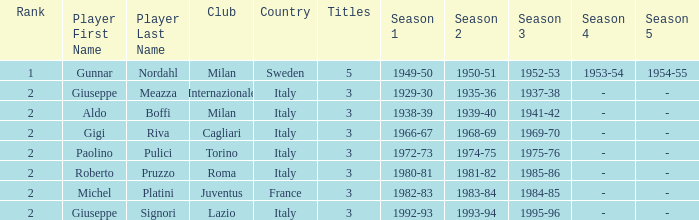How many rankings are associated with giuseppe meazza holding over 3 titles? 0.0. 